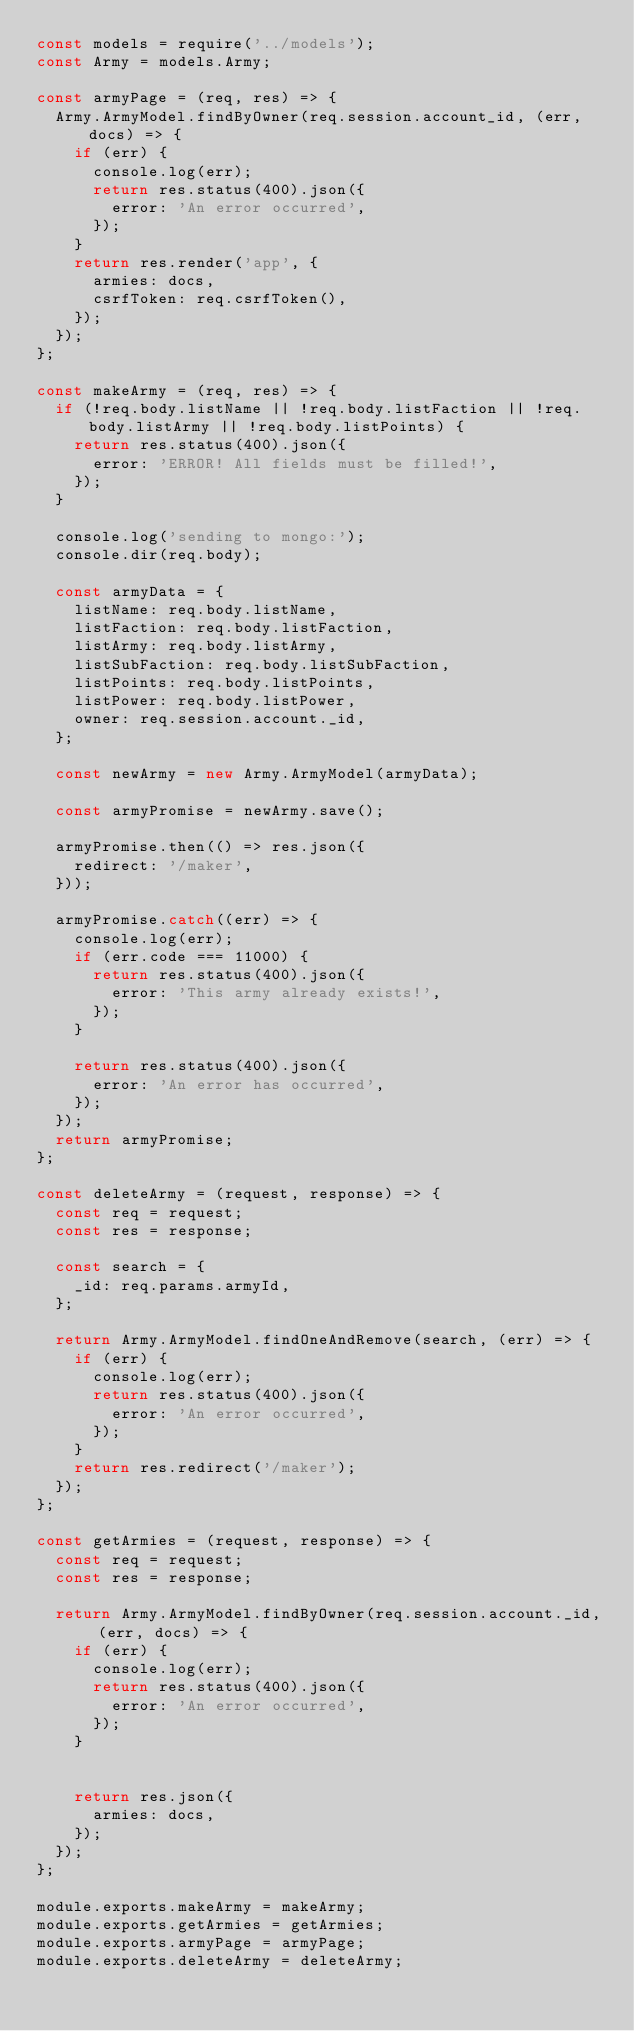Convert code to text. <code><loc_0><loc_0><loc_500><loc_500><_JavaScript_>const models = require('../models');
const Army = models.Army;

const armyPage = (req, res) => {
  Army.ArmyModel.findByOwner(req.session.account_id, (err, docs) => {
    if (err) {
      console.log(err);
      return res.status(400).json({
        error: 'An error occurred',
      });
    }
    return res.render('app', {
      armies: docs,
      csrfToken: req.csrfToken(),
    });
  });
};

const makeArmy = (req, res) => {
  if (!req.body.listName || !req.body.listFaction || !req.body.listArmy || !req.body.listPoints) {
    return res.status(400).json({
      error: 'ERROR! All fields must be filled!',
    });
  }

  console.log('sending to mongo:');
  console.dir(req.body);

  const armyData = {
    listName: req.body.listName,
    listFaction: req.body.listFaction,
    listArmy: req.body.listArmy,
    listSubFaction: req.body.listSubFaction,
    listPoints: req.body.listPoints,
    listPower: req.body.listPower,
    owner: req.session.account._id,
  };

  const newArmy = new Army.ArmyModel(armyData);

  const armyPromise = newArmy.save();

  armyPromise.then(() => res.json({
    redirect: '/maker',
  }));

  armyPromise.catch((err) => {
    console.log(err);
    if (err.code === 11000) {
      return res.status(400).json({
        error: 'This army already exists!',
      });
    }

    return res.status(400).json({
      error: 'An error has occurred',
    });
  });
  return armyPromise;
};

const deleteArmy = (request, response) => {
  const req = request;
  const res = response;

  const search = {
    _id: req.params.armyId,
  };

  return Army.ArmyModel.findOneAndRemove(search, (err) => {
    if (err) {
      console.log(err);
      return res.status(400).json({
        error: 'An error occurred',
      });
    }
    return res.redirect('/maker');
  });
};

const getArmies = (request, response) => {
  const req = request;
  const res = response;

  return Army.ArmyModel.findByOwner(req.session.account._id, (err, docs) => {
    if (err) {
      console.log(err);
      return res.status(400).json({
        error: 'An error occurred',
      });
    }


    return res.json({
      armies: docs,
    });
  });
};

module.exports.makeArmy = makeArmy;
module.exports.getArmies = getArmies;
module.exports.armyPage = armyPage;
module.exports.deleteArmy = deleteArmy;
</code> 